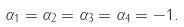<formula> <loc_0><loc_0><loc_500><loc_500>\alpha _ { 1 } = \alpha _ { 2 } = \alpha _ { 3 } = \alpha _ { 4 } = - 1 .</formula> 